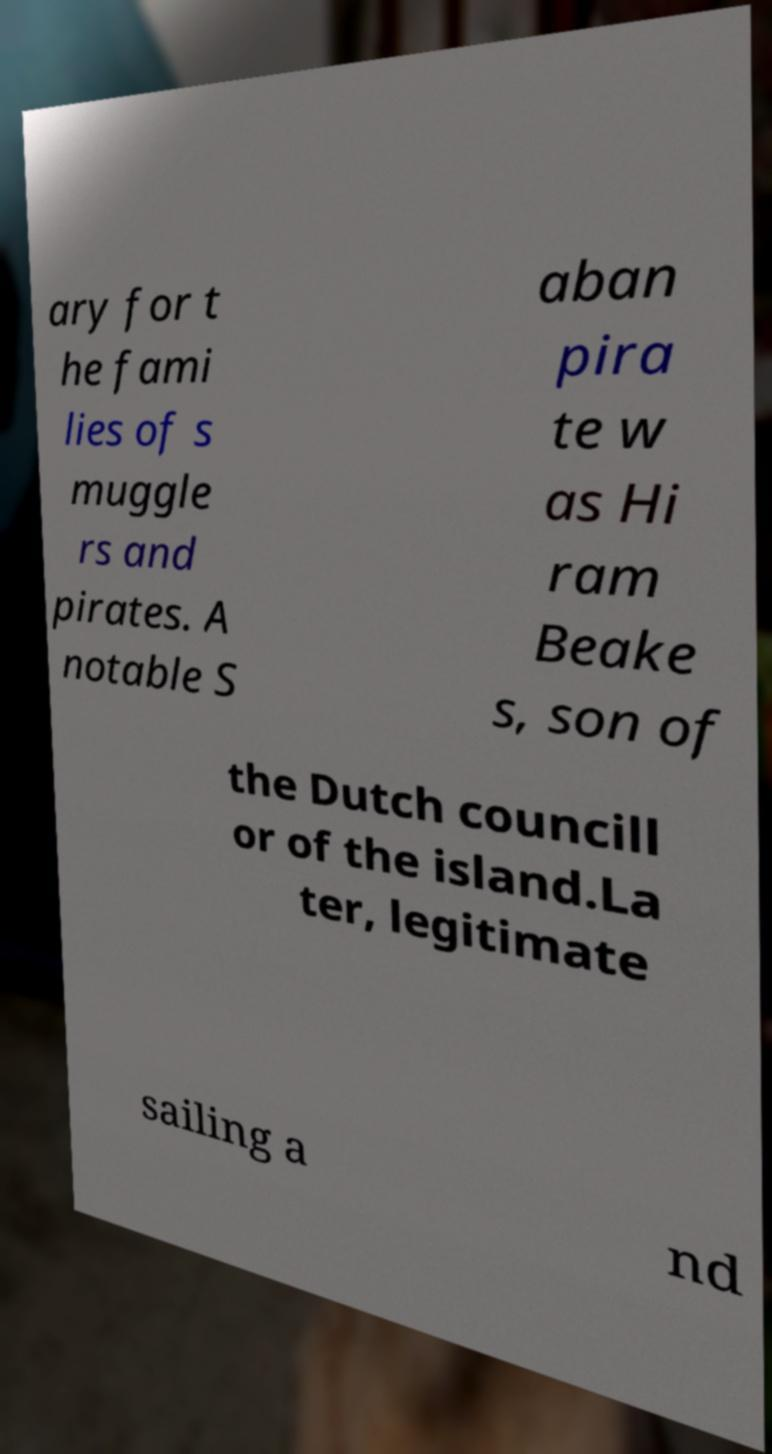There's text embedded in this image that I need extracted. Can you transcribe it verbatim? ary for t he fami lies of s muggle rs and pirates. A notable S aban pira te w as Hi ram Beake s, son of the Dutch councill or of the island.La ter, legitimate sailing a nd 